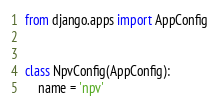Convert code to text. <code><loc_0><loc_0><loc_500><loc_500><_Python_>from django.apps import AppConfig


class NpvConfig(AppConfig):
    name = 'npv'
</code> 